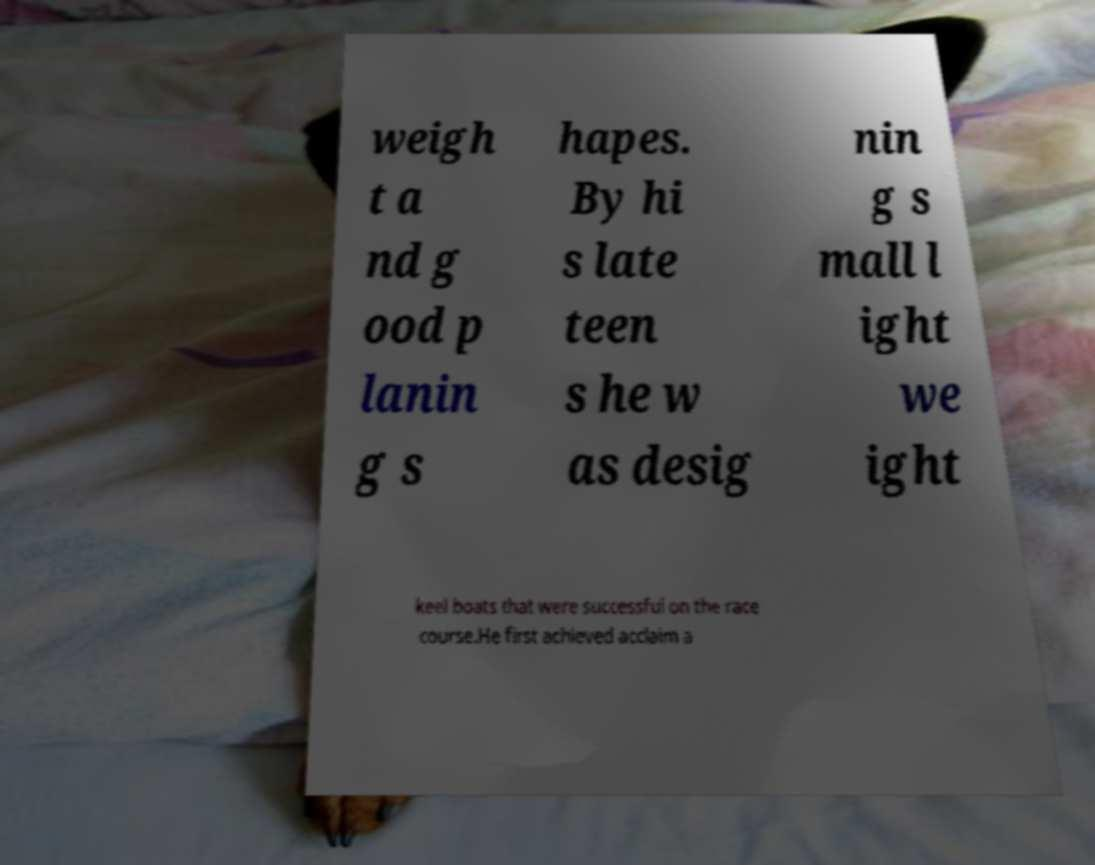Could you assist in decoding the text presented in this image and type it out clearly? weigh t a nd g ood p lanin g s hapes. By hi s late teen s he w as desig nin g s mall l ight we ight keel boats that were successful on the race course.He first achieved acclaim a 